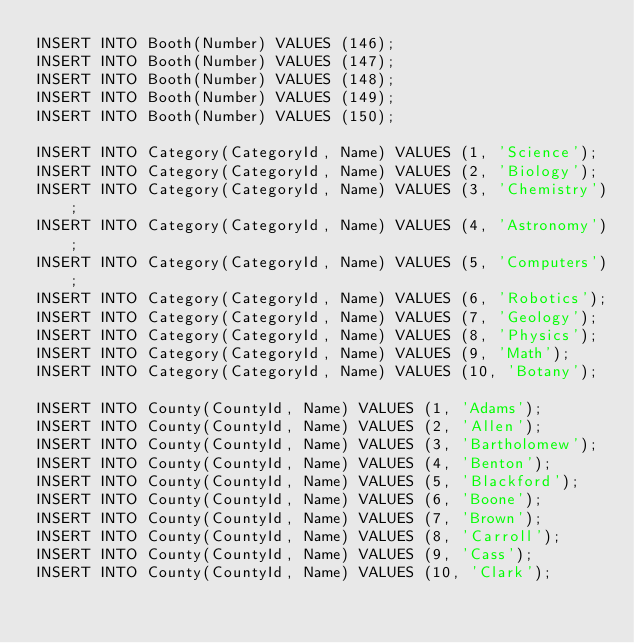<code> <loc_0><loc_0><loc_500><loc_500><_SQL_>INSERT INTO Booth(Number) VALUES (146);
INSERT INTO Booth(Number) VALUES (147);
INSERT INTO Booth(Number) VALUES (148);
INSERT INTO Booth(Number) VALUES (149);
INSERT INTO Booth(Number) VALUES (150);

INSERT INTO Category(CategoryId, Name) VALUES (1, 'Science');
INSERT INTO Category(CategoryId, Name) VALUES (2, 'Biology');
INSERT INTO Category(CategoryId, Name) VALUES (3, 'Chemistry');
INSERT INTO Category(CategoryId, Name) VALUES (4, 'Astronomy');
INSERT INTO Category(CategoryId, Name) VALUES (5, 'Computers');
INSERT INTO Category(CategoryId, Name) VALUES (6, 'Robotics');
INSERT INTO Category(CategoryId, Name) VALUES (7, 'Geology');
INSERT INTO Category(CategoryId, Name) VALUES (8, 'Physics');
INSERT INTO Category(CategoryId, Name) VALUES (9, 'Math');
INSERT INTO Category(CategoryId, Name) VALUES (10, 'Botany');

INSERT INTO County(CountyId, Name) VALUES (1, 'Adams');
INSERT INTO County(CountyId, Name) VALUES (2, 'Allen');
INSERT INTO County(CountyId, Name) VALUES (3, 'Bartholomew');
INSERT INTO County(CountyId, Name) VALUES (4, 'Benton');
INSERT INTO County(CountyId, Name) VALUES (5, 'Blackford');
INSERT INTO County(CountyId, Name) VALUES (6, 'Boone');
INSERT INTO County(CountyId, Name) VALUES (7, 'Brown');
INSERT INTO County(CountyId, Name) VALUES (8, 'Carroll');
INSERT INTO County(CountyId, Name) VALUES (9, 'Cass');
INSERT INTO County(CountyId, Name) VALUES (10, 'Clark');</code> 